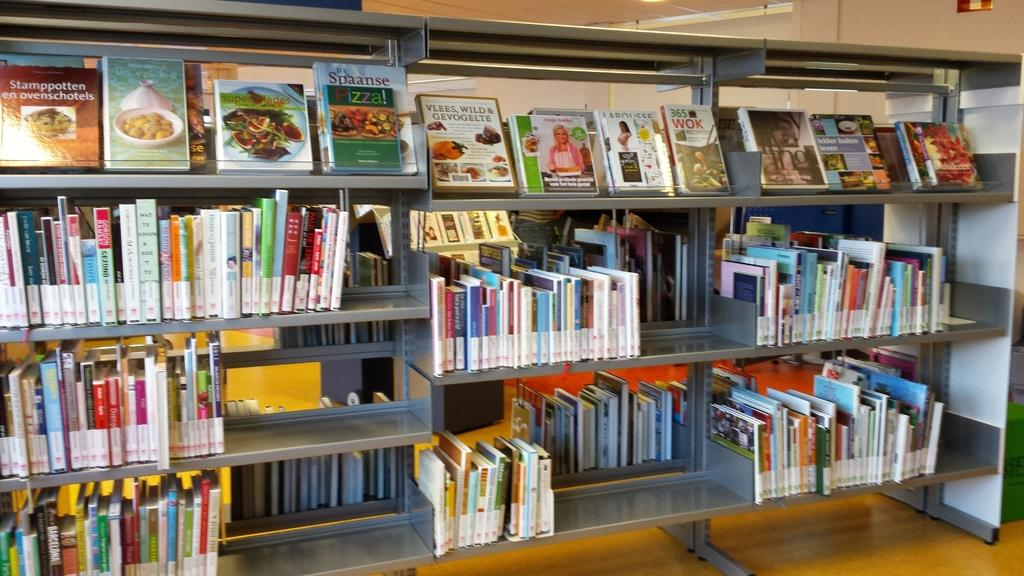<image>
Provide a brief description of the given image. Spaanse Pizza is among the books on the shelves. 